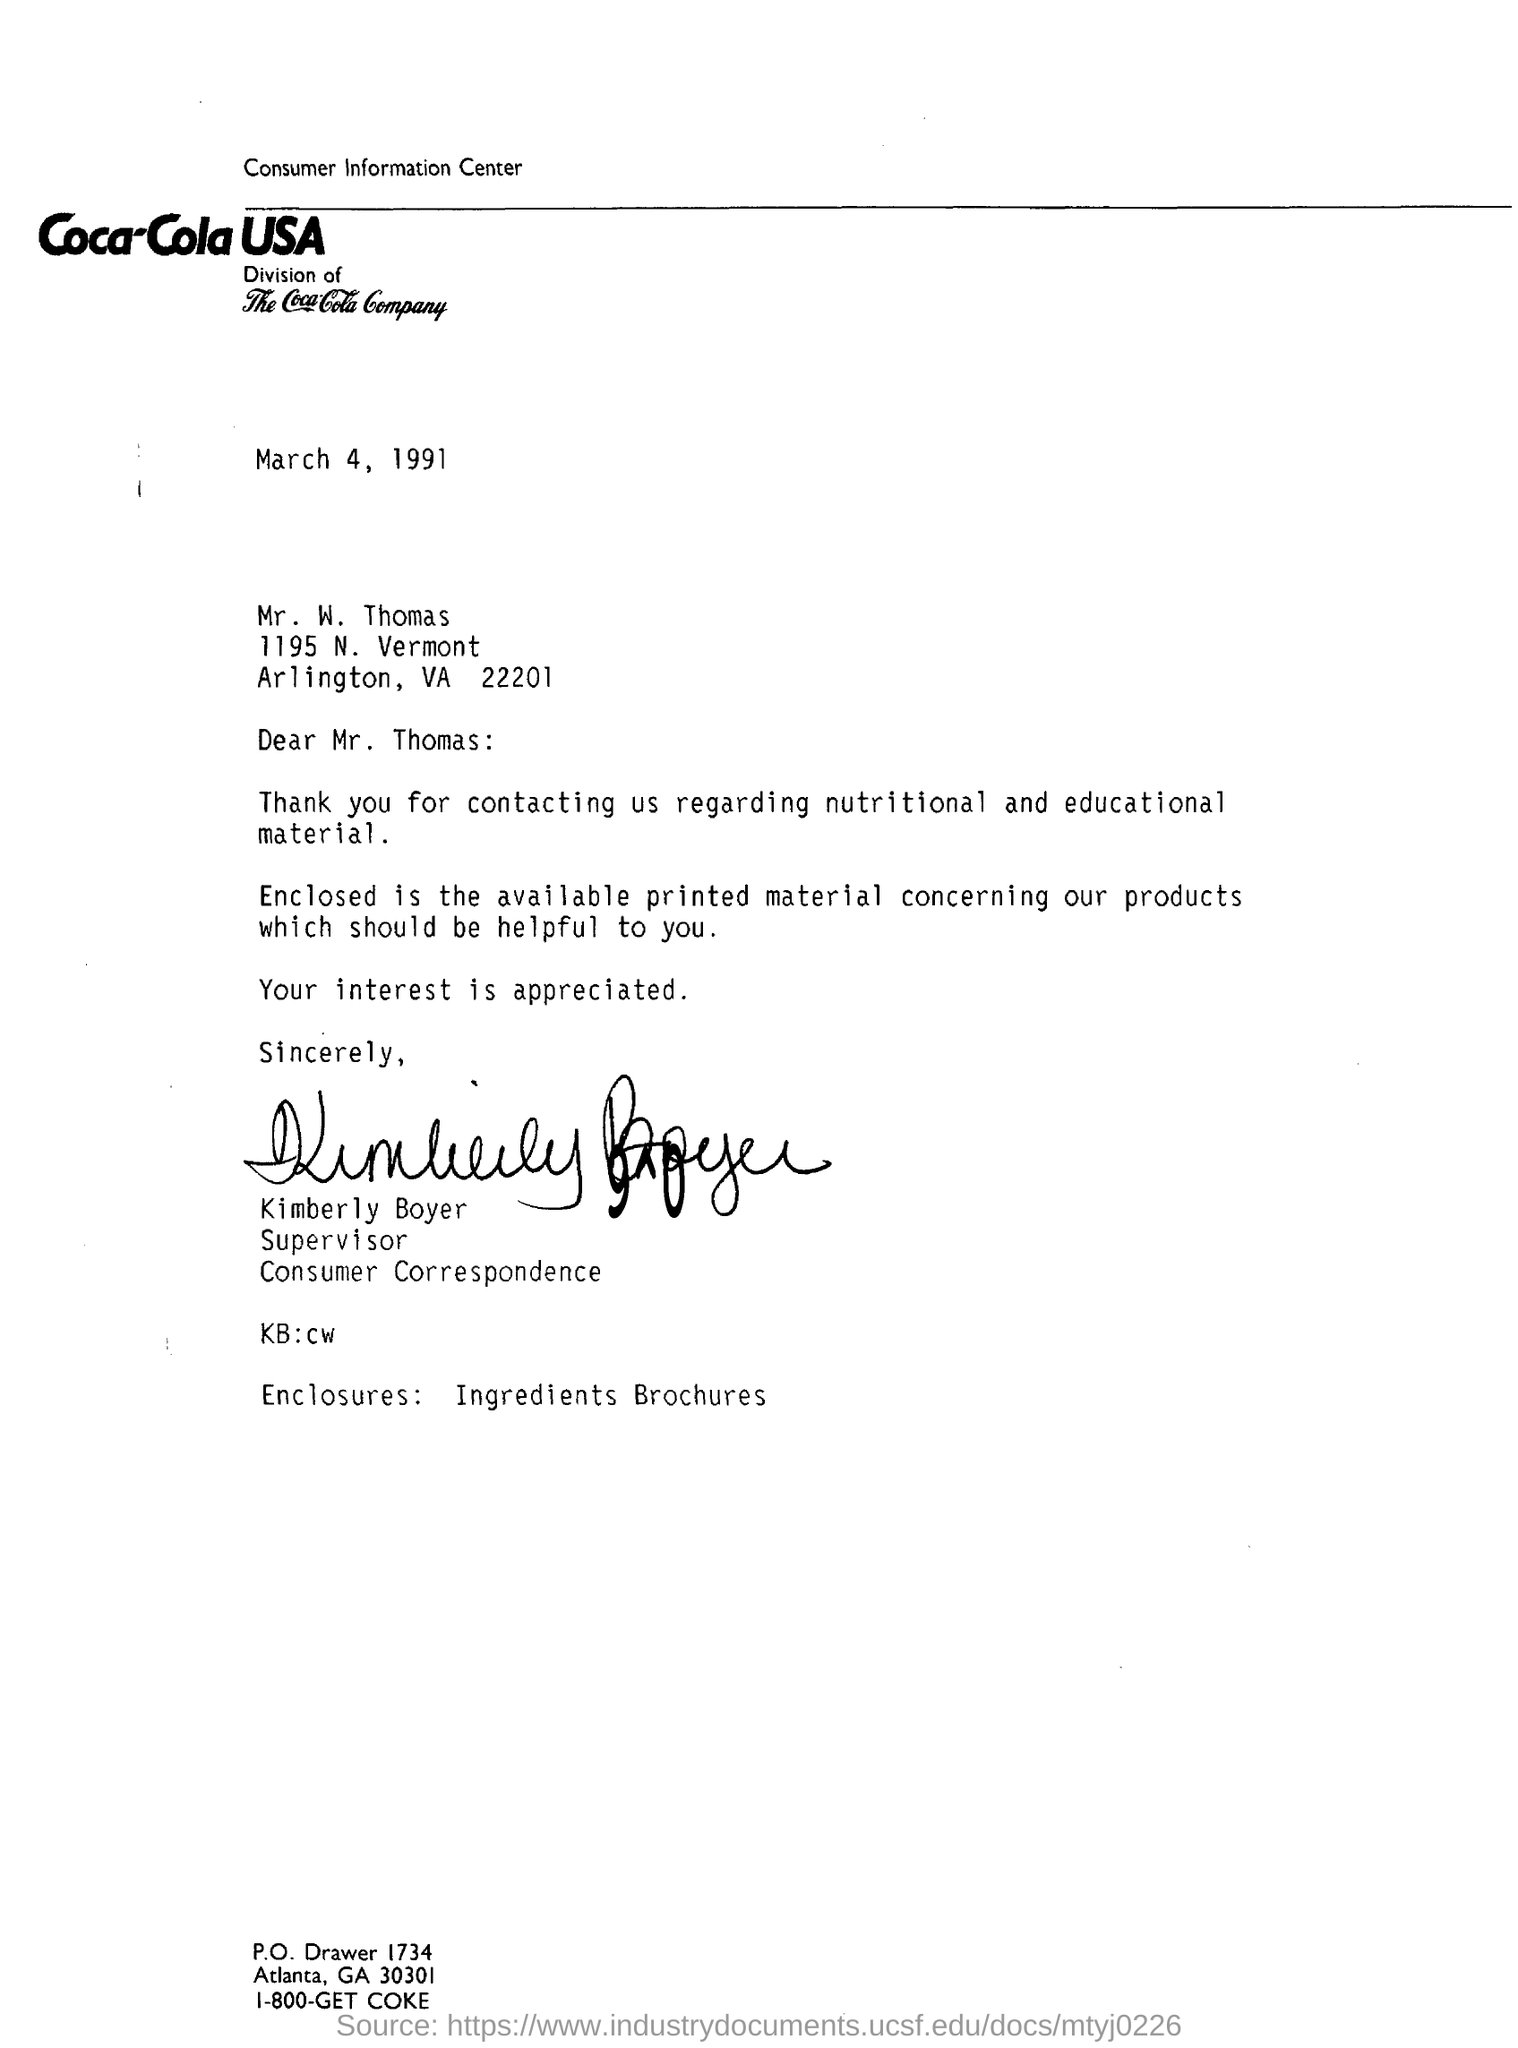Draw attention to some important aspects in this diagram. The letter is addressed to Mr. Thomas. The date mentioned in the letter is March 4, 1991. The consumer correspondence of Coca-Cola USA is Kimberly Boyer. 